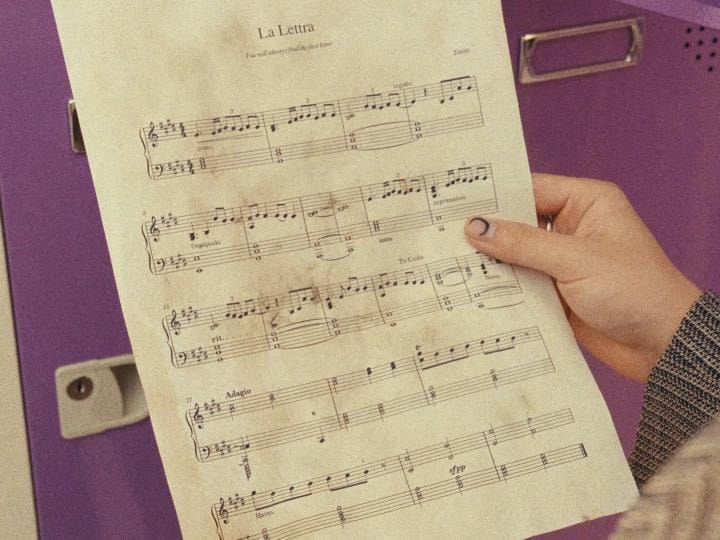What's the weird thing about the image? The weird thing about the image is that the sheet music is blank. 